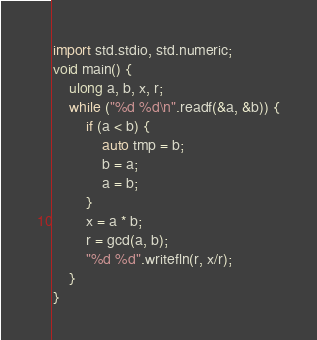<code> <loc_0><loc_0><loc_500><loc_500><_D_>import std.stdio, std.numeric;
void main() {
	ulong a, b, x, r;
	while ("%d %d\n".readf(&a, &b)) {
		if (a < b) {
			auto tmp = b;
			b = a;
			a = b;
		}
		x = a * b;
		r = gcd(a, b);
		"%d %d".writefln(r, x/r);
	}
}</code> 